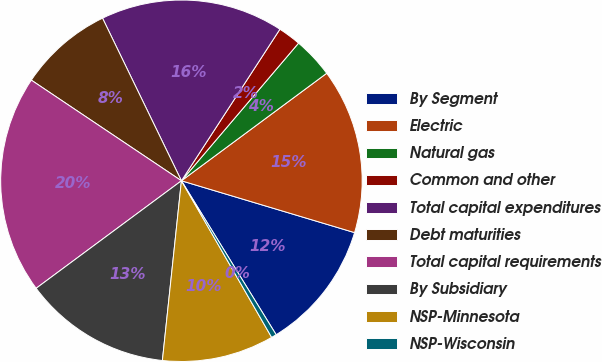Convert chart. <chart><loc_0><loc_0><loc_500><loc_500><pie_chart><fcel>By Segment<fcel>Electric<fcel>Natural gas<fcel>Common and other<fcel>Total capital expenditures<fcel>Debt maturities<fcel>Total capital requirements<fcel>By Subsidiary<fcel>NSP-Minnesota<fcel>NSP-Wisconsin<nl><fcel>11.59%<fcel>14.77%<fcel>3.64%<fcel>2.05%<fcel>16.36%<fcel>8.41%<fcel>19.54%<fcel>13.18%<fcel>10.0%<fcel>0.46%<nl></chart> 